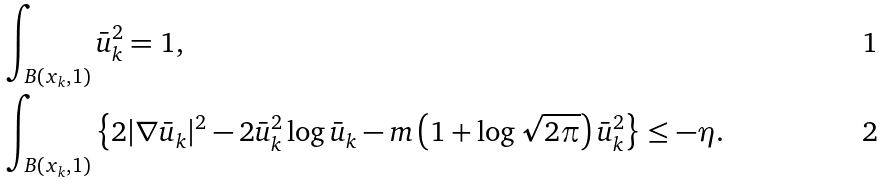<formula> <loc_0><loc_0><loc_500><loc_500>& \int _ { B ( x _ { k } , 1 ) } \bar { u } _ { k } ^ { 2 } = 1 , \\ & \int _ { B ( x _ { k } , 1 ) } \left \{ 2 | \nabla \bar { u } _ { k } | ^ { 2 } - 2 \bar { u } _ { k } ^ { 2 } \log \bar { u } _ { k } - m \left ( 1 + \log \sqrt { 2 \pi } \right ) \bar { u } _ { k } ^ { 2 } \right \} \leq - \eta .</formula> 